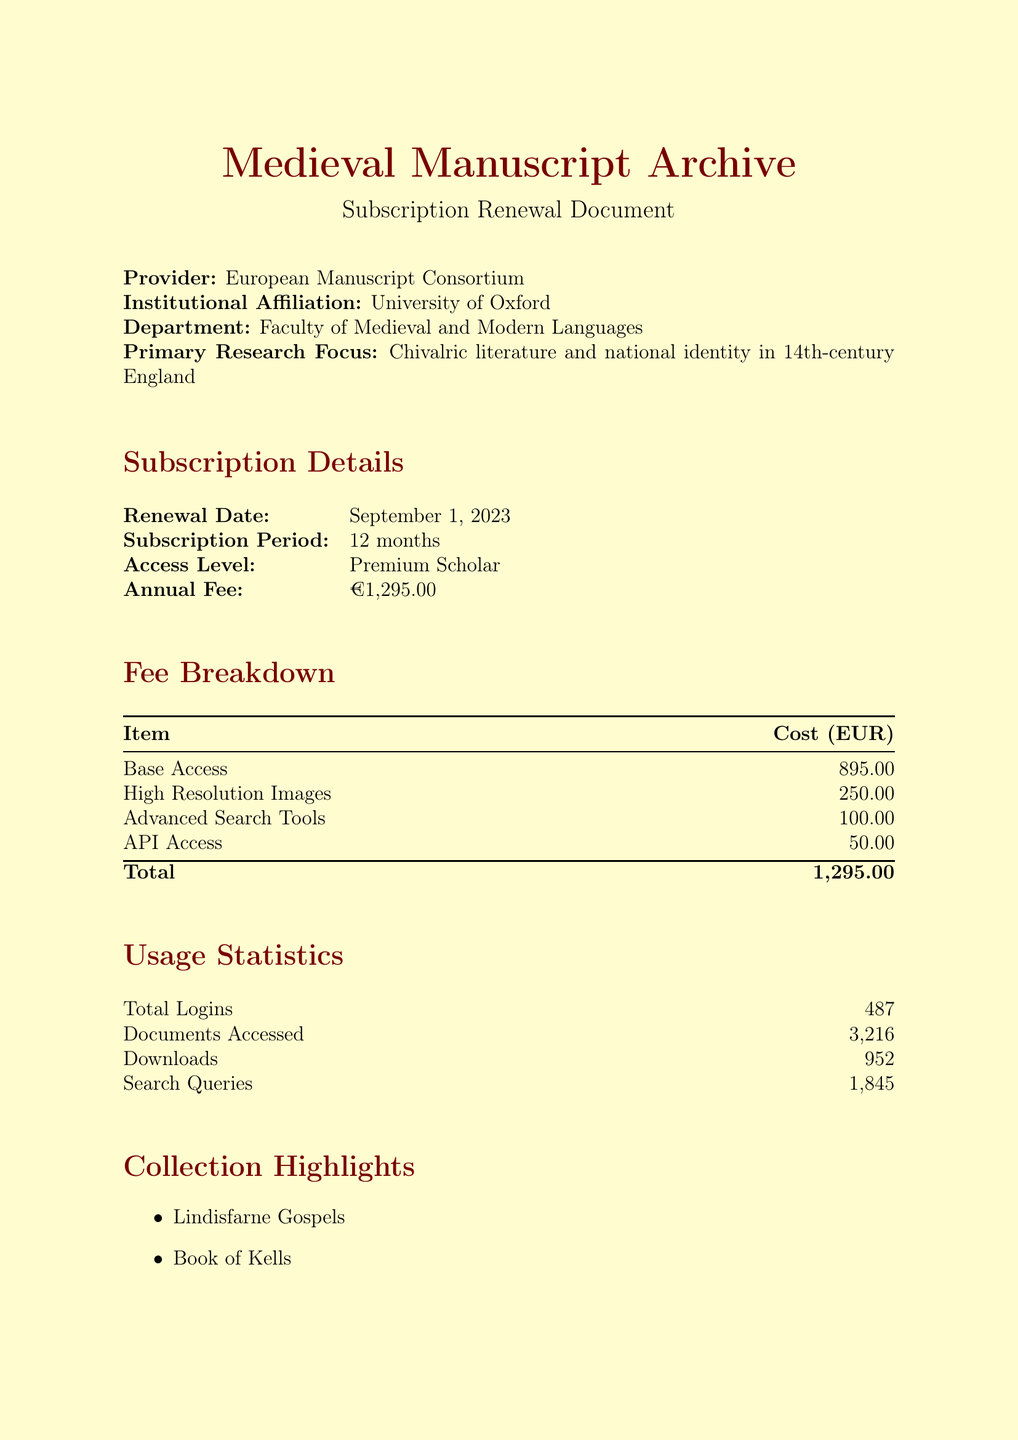What is the name of the database? The name of the database is indicated prominently in the document, which is "Medieval Manuscript Archive."
Answer: Medieval Manuscript Archive What is the annual fee for the subscription? The annual fee is provided in the subscription details section, stating it clearly as €1,295.00.
Answer: €1,295.00 How many total logins were recorded? The usage statistics section includes the total logins number, which is reported as 487.
Answer: 487 What is the primary research focus of the institution? The document specifies the primary research focus under the institutional details, which is "Chivalric literature and national identity in 14th-century England."
Answer: Chivalric literature and national identity in 14th-century England What are the payment options for the subscription? The document outlines multiple payment options, which are mentioned in the payment options section of the document.
Answer: Annual Lump Sum, Quarterly Installments, Monthly Installments How many documents were accessed during the subscription period? The usage statistics state the number of documents accessed, which is recorded as 3,216.
Answer: 3,216 Which collaborative project is mentioned? The document lists a specific collaborative project along with its partner institution, highlighting it under the collaborative projects section.
Answer: Digital Humanities Initiative for Medieval Studies When is the renewal date for the subscription? The renewal date is explicitly stated in the subscription details section, denoting when the subscription will be renewed.
Answer: September 1, 2023 